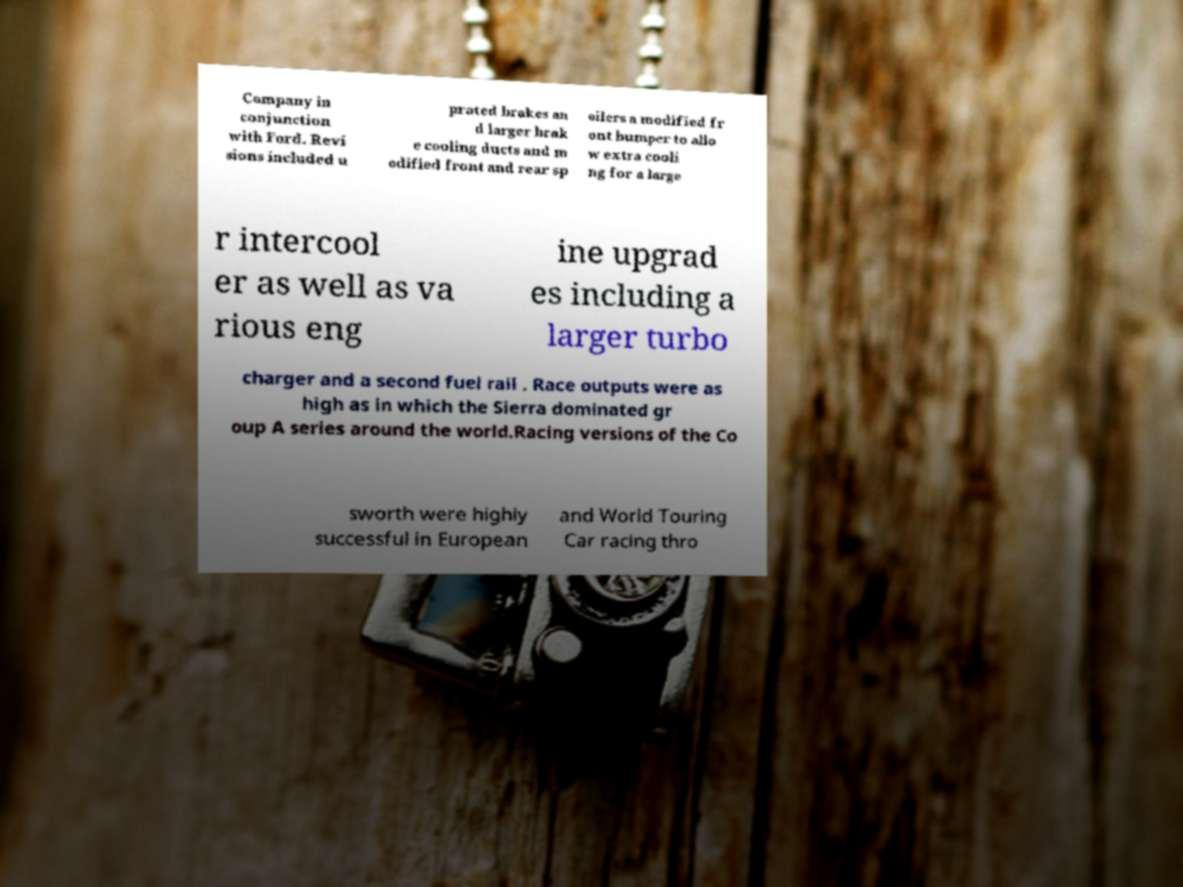For documentation purposes, I need the text within this image transcribed. Could you provide that? Company in conjunction with Ford. Revi sions included u prated brakes an d larger brak e cooling ducts and m odified front and rear sp oilers a modified fr ont bumper to allo w extra cooli ng for a large r intercool er as well as va rious eng ine upgrad es including a larger turbo charger and a second fuel rail . Race outputs were as high as in which the Sierra dominated gr oup A series around the world.Racing versions of the Co sworth were highly successful in European and World Touring Car racing thro 